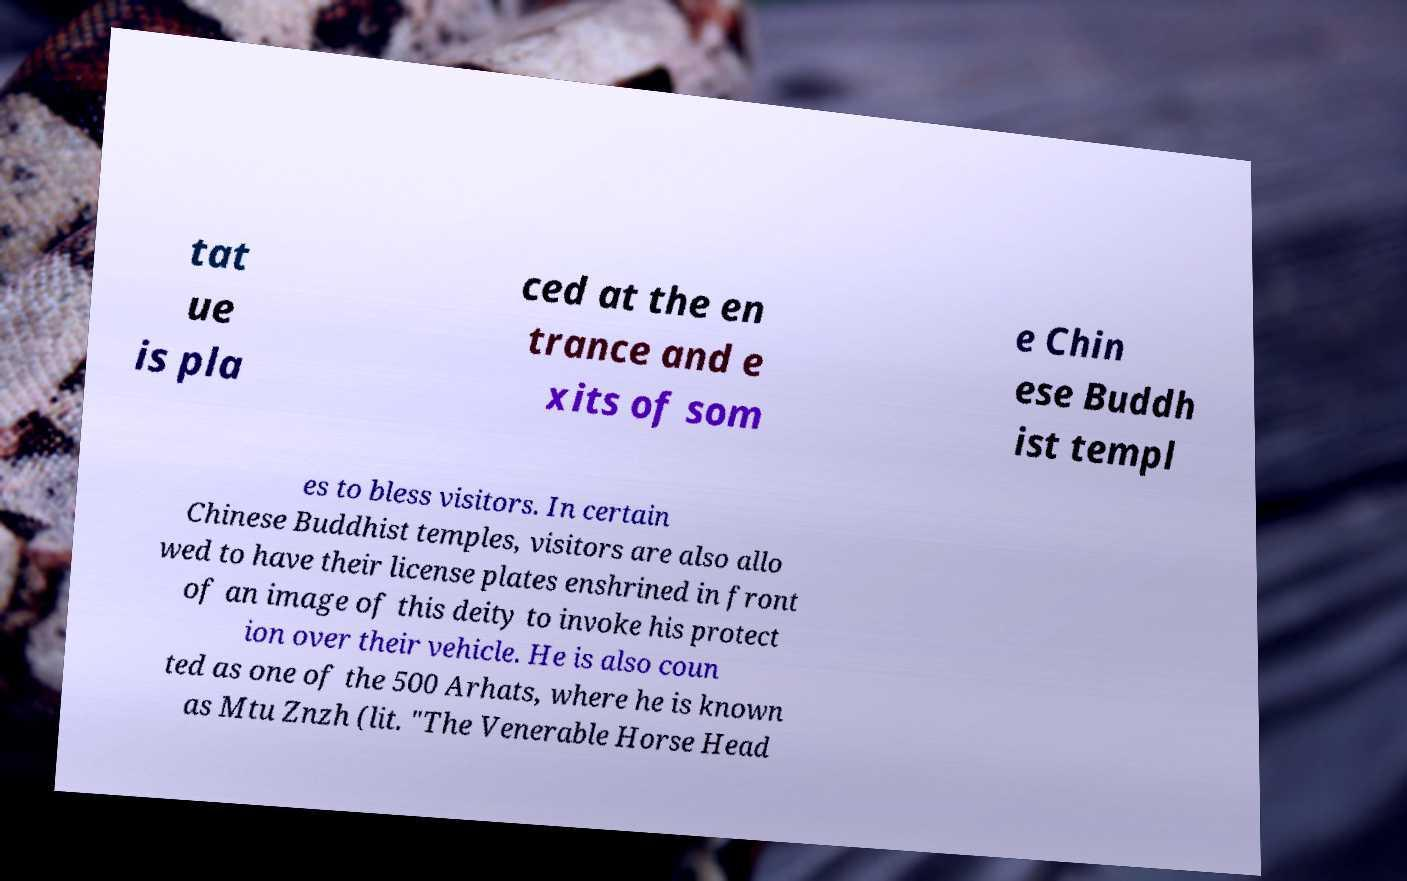Please read and relay the text visible in this image. What does it say? tat ue is pla ced at the en trance and e xits of som e Chin ese Buddh ist templ es to bless visitors. In certain Chinese Buddhist temples, visitors are also allo wed to have their license plates enshrined in front of an image of this deity to invoke his protect ion over their vehicle. He is also coun ted as one of the 500 Arhats, where he is known as Mtu Znzh (lit. "The Venerable Horse Head 